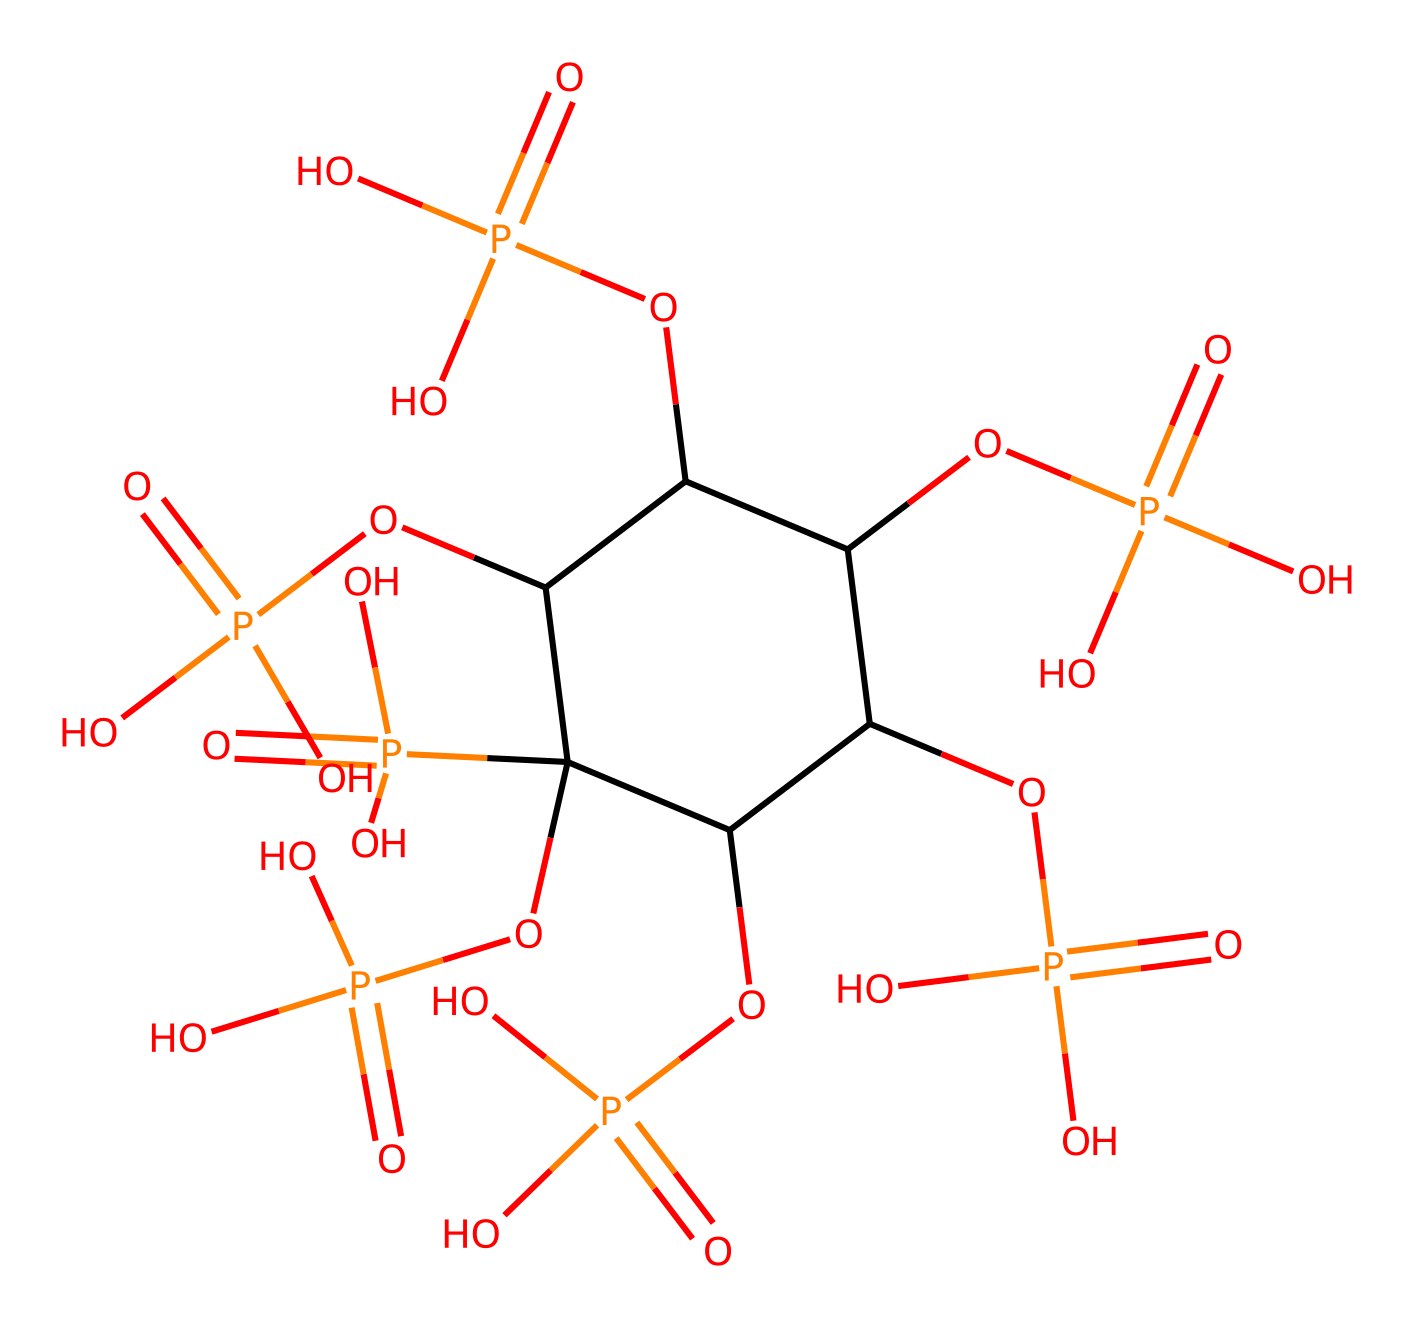What is the molecular formula of phytic acid? To determine the molecular formula, we examine the structure represented by the SMILES. The main components visible are phosphorus (P), oxygen (O), and carbon (C). The molecular formula for phytic acid is formed by counting each of these atoms in the provided structure. The count yields C6H18O24P6.
Answer: C6H18O24P6 How many phosphorus atoms are present in phytic acid? By analyzing the SMILES representation, each occurrence of the phosphorous component (P) corresponds to one phosphorus atom. Counting these, we find a total of 6 phosphorus atoms in the molecule.
Answer: 6 What type of compound is phytic acid? The presence of phosphorus and multiple phosphoric acid groups characterizes phytic acid as a polyphosphate compound. This classification is based on the structure containing multiple phosphate (P-O) groups linked together.
Answer: polyphosphate How many hydroxyl groups are in phytic acid? The hydroxyl groups are indicated by oxygen atoms bonded to hydrogen in the SMILES structure. We can identify these by finding where oxygen atoms are adjacent to carbon atoms without being part of phosphate groups. Counting these, we find there are 6 hydroxyl groups in total.
Answer: 6 What functional groups are predominantly found in phytic acid? Phytic acid predominantly contains phosphate (P) functional groups and hydroxyl (OH) groups. The presence of these features can be directly observed in the SMILES structure, where we see multiple P atoms and several OH connections.
Answer: phosphate, hydroxyl How many cyclic structures are present in phytic acid? The structure has one cycloalkane portion as indicated by the circular notation of the carbons and connecting phosphorus groups. This indicates a cyclic arrangement involving the carbons for one complete ring.
Answer: 1 